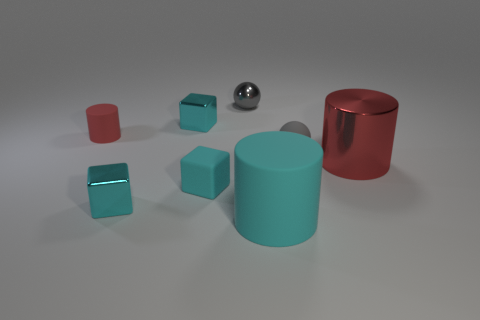What number of green objects are small metal cubes or big rubber things?
Your answer should be very brief. 0. Do the sphere behind the tiny red thing and the cyan cylinder have the same material?
Your answer should be very brief. No. How many other things are there of the same material as the big cyan thing?
Offer a terse response. 3. What is the material of the tiny cylinder?
Your answer should be compact. Rubber. There is a cylinder to the left of the gray metallic sphere; how big is it?
Make the answer very short. Small. There is a small cyan object that is behind the rubber block; how many cyan metal cubes are behind it?
Keep it short and to the point. 0. Do the small matte thing that is in front of the red shiny cylinder and the matte object in front of the rubber block have the same shape?
Make the answer very short. No. What number of big things are both behind the large matte thing and to the left of the gray matte object?
Your response must be concise. 0. Is there a cube that has the same color as the large matte object?
Provide a succinct answer. Yes. There is a red rubber object that is the same size as the rubber ball; what is its shape?
Offer a very short reply. Cylinder. 